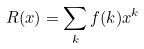Convert formula to latex. <formula><loc_0><loc_0><loc_500><loc_500>R ( x ) = \sum _ { k } f ( k ) x ^ { k }</formula> 